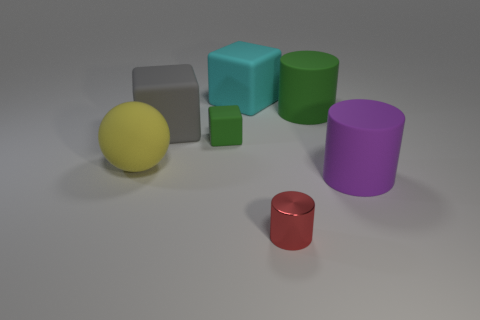Add 1 tiny cyan metal blocks. How many objects exist? 8 Subtract all cylinders. How many objects are left? 4 Add 7 big green rubber things. How many big green rubber things are left? 8 Add 1 small green cylinders. How many small green cylinders exist? 1 Subtract 0 purple balls. How many objects are left? 7 Subtract all cyan rubber cubes. Subtract all yellow rubber objects. How many objects are left? 5 